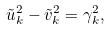Convert formula to latex. <formula><loc_0><loc_0><loc_500><loc_500>\tilde { u } _ { k } ^ { 2 } - \tilde { v } _ { k } ^ { 2 } = \gamma _ { k } ^ { 2 } ,</formula> 